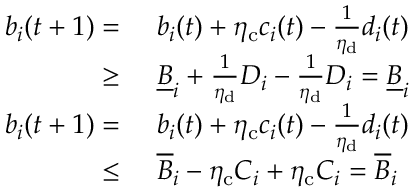<formula> <loc_0><loc_0><loc_500><loc_500>\begin{array} { r l } { b _ { i } ( t + 1 ) = } & { b _ { i } ( t ) + \eta _ { c } c _ { i } ( t ) - \frac { 1 } { \eta _ { d } } d _ { i } ( t ) } \\ { \geq } & { \underline { B } _ { i } + \frac { 1 } { \eta _ { d } } D _ { i } - \frac { 1 } { \eta _ { d } } D _ { i } = \underline { B } _ { i } } \\ { b _ { i } ( t + 1 ) = } & { b _ { i } ( t ) + \eta _ { c } c _ { i } ( t ) - \frac { 1 } { \eta _ { d } } d _ { i } ( t ) } \\ { \leq } & { \overline { B } _ { i } - \eta _ { c } C _ { i } + \eta _ { c } C _ { i } = \overline { B } _ { i } } \end{array}</formula> 